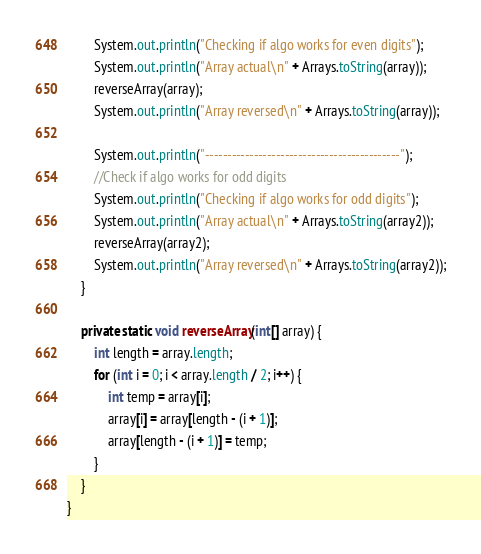Convert code to text. <code><loc_0><loc_0><loc_500><loc_500><_Java_>        System.out.println("Checking if algo works for even digits");
        System.out.println("Array actual\n" + Arrays.toString(array));
        reverseArray(array);
        System.out.println("Array reversed\n" + Arrays.toString(array));

        System.out.println("--------------------------------------------");
        //Check if algo works for odd digits
        System.out.println("Checking if algo works for odd digits");
        System.out.println("Array actual\n" + Arrays.toString(array2));
        reverseArray(array2);
        System.out.println("Array reversed\n" + Arrays.toString(array2));
    }

    private static void reverseArray(int[] array) {
        int length = array.length;
        for (int i = 0; i < array.length / 2; i++) {
            int temp = array[i];
            array[i] = array[length - (i + 1)];
            array[length - (i + 1)] = temp;
        }
    }
}
</code> 